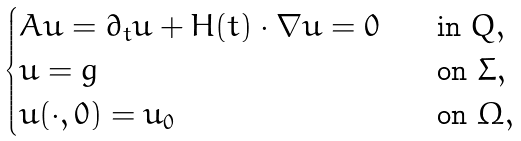<formula> <loc_0><loc_0><loc_500><loc_500>\begin{cases} A u = \partial _ { t } u + H ( t ) \cdot \nabla u = 0 \quad & \text {in} \ Q , \\ u = g \quad & \text {on} \ \Sigma , \\ u ( \cdot , 0 ) = u _ { 0 } \quad & \text {on} \ \Omega , \end{cases}</formula> 